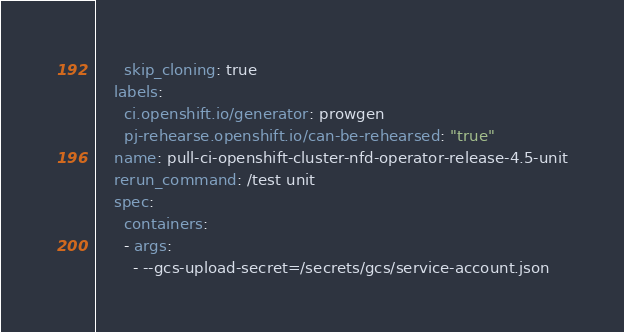Convert code to text. <code><loc_0><loc_0><loc_500><loc_500><_YAML_>      skip_cloning: true
    labels:
      ci.openshift.io/generator: prowgen
      pj-rehearse.openshift.io/can-be-rehearsed: "true"
    name: pull-ci-openshift-cluster-nfd-operator-release-4.5-unit
    rerun_command: /test unit
    spec:
      containers:
      - args:
        - --gcs-upload-secret=/secrets/gcs/service-account.json</code> 